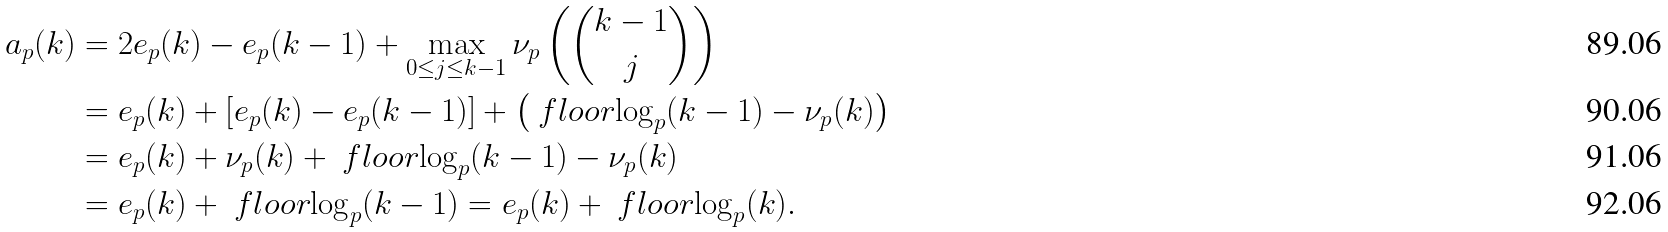<formula> <loc_0><loc_0><loc_500><loc_500>a _ { p } ( k ) & = 2 e _ { p } ( k ) - e _ { p } ( k - 1 ) + \max _ { 0 \leq j \leq k - 1 } \nu _ { p } \left ( \binom { k - 1 } { j } \right ) \\ & = e _ { p } ( k ) + \left [ e _ { p } ( k ) - e _ { p } ( k - 1 ) \right ] + \left ( \ f l o o r { \log _ { p } ( k - 1 ) } - \nu _ { p } ( k ) \right ) \\ & = e _ { p } ( k ) + \nu _ { p } ( k ) + \ f l o o r { \log _ { p } ( k - 1 ) } - \nu _ { p } ( k ) \\ & = e _ { p } ( k ) + \ f l o o r { \log _ { p } ( k - 1 ) } = e _ { p } ( k ) + \ f l o o r { \log _ { p } ( k ) } .</formula> 